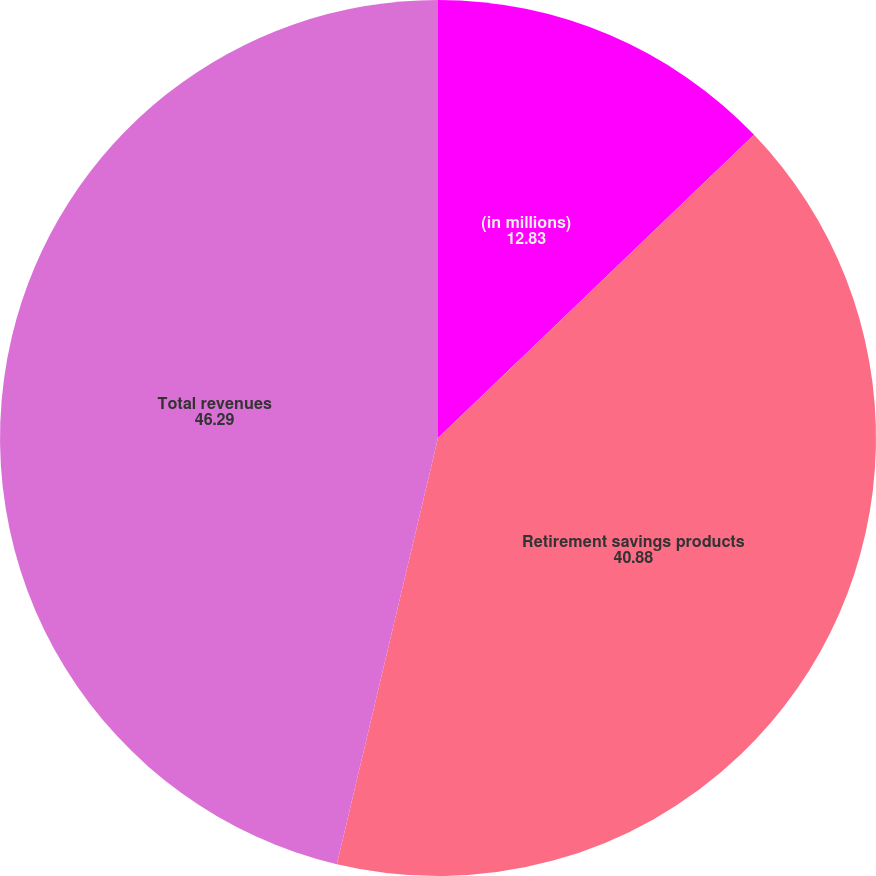Convert chart to OTSL. <chart><loc_0><loc_0><loc_500><loc_500><pie_chart><fcel>(in millions)<fcel>Retirement savings products<fcel>Total revenues<nl><fcel>12.83%<fcel>40.88%<fcel>46.29%<nl></chart> 